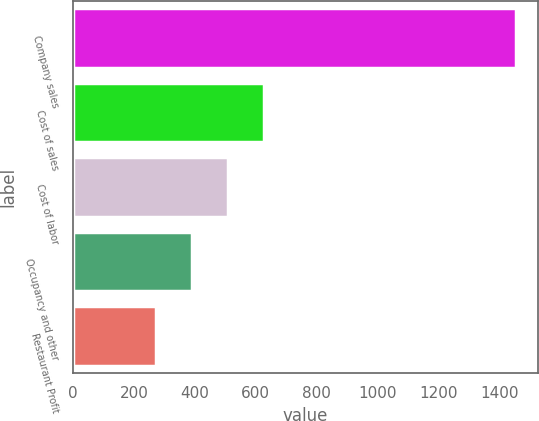<chart> <loc_0><loc_0><loc_500><loc_500><bar_chart><fcel>Company sales<fcel>Cost of sales<fcel>Cost of labor<fcel>Occupancy and other<fcel>Restaurant Profit<nl><fcel>1452<fcel>627.4<fcel>509.6<fcel>391.8<fcel>274<nl></chart> 